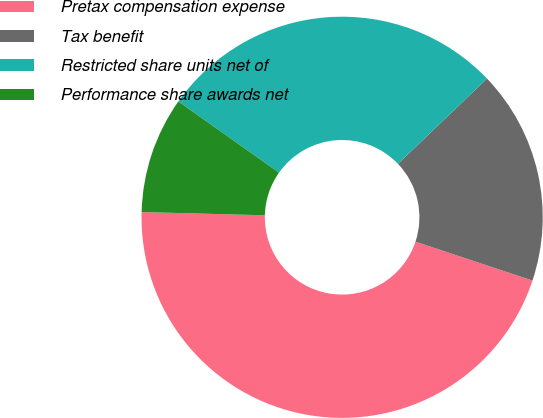<chart> <loc_0><loc_0><loc_500><loc_500><pie_chart><fcel>Pretax compensation expense<fcel>Tax benefit<fcel>Restricted share units net of<fcel>Performance share awards net<nl><fcel>45.31%<fcel>17.26%<fcel>28.05%<fcel>9.38%<nl></chart> 